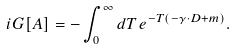<formula> <loc_0><loc_0><loc_500><loc_500>i G [ A ] = - \int _ { 0 } ^ { \infty } d T \, e ^ { - T ( - \gamma \cdot D + m ) } .</formula> 